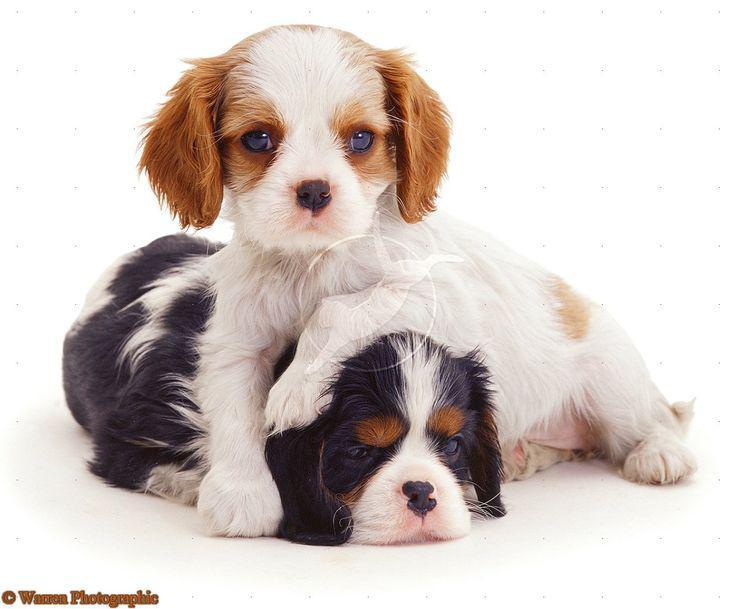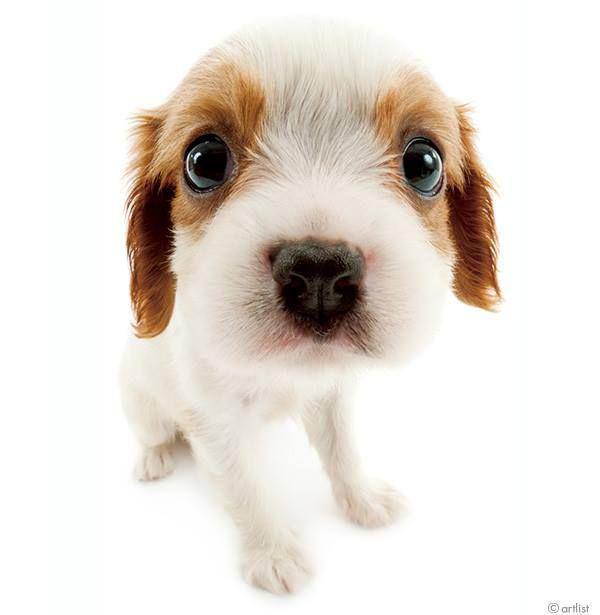The first image is the image on the left, the second image is the image on the right. For the images shown, is this caption "One image shows a nursing mother spaniel with several spotted puppies." true? Answer yes or no. No. 